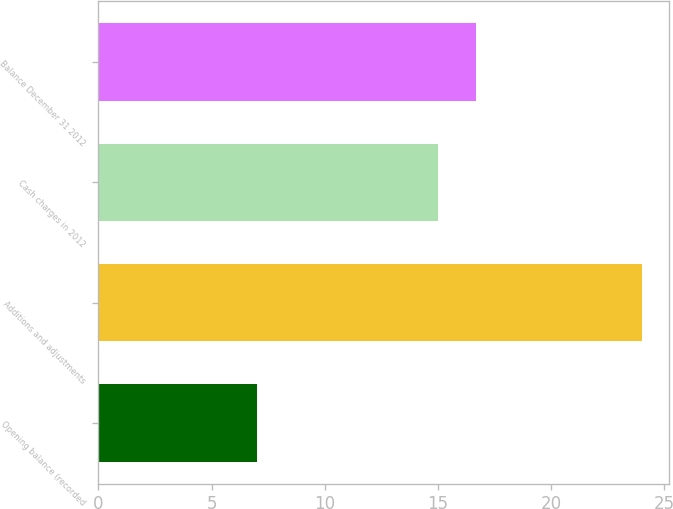Convert chart. <chart><loc_0><loc_0><loc_500><loc_500><bar_chart><fcel>Opening balance (recorded<fcel>Additions and adjustments<fcel>Cash charges in 2012<fcel>Balance December 31 2012<nl><fcel>7<fcel>24<fcel>15<fcel>16.7<nl></chart> 